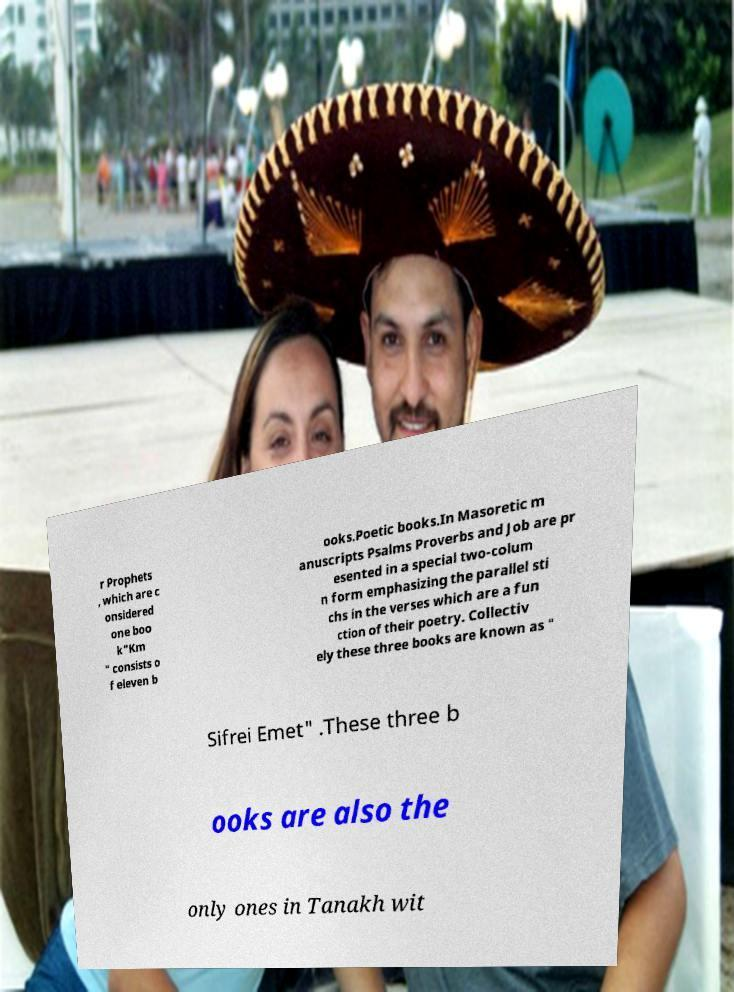I need the written content from this picture converted into text. Can you do that? r Prophets , which are c onsidered one boo k"Km " consists o f eleven b ooks.Poetic books.In Masoretic m anuscripts Psalms Proverbs and Job are pr esented in a special two-colum n form emphasizing the parallel sti chs in the verses which are a fun ction of their poetry. Collectiv ely these three books are known as " Sifrei Emet" .These three b ooks are also the only ones in Tanakh wit 